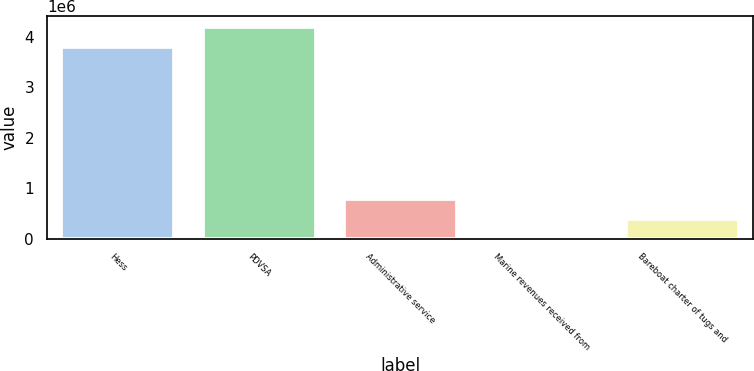<chart> <loc_0><loc_0><loc_500><loc_500><bar_chart><fcel>Hess<fcel>PDVSA<fcel>Administrative service<fcel>Marine revenues received from<fcel>Bareboat charter of tugs and<nl><fcel>3.80582e+06<fcel>4.19952e+06<fcel>787968<fcel>567<fcel>394267<nl></chart> 